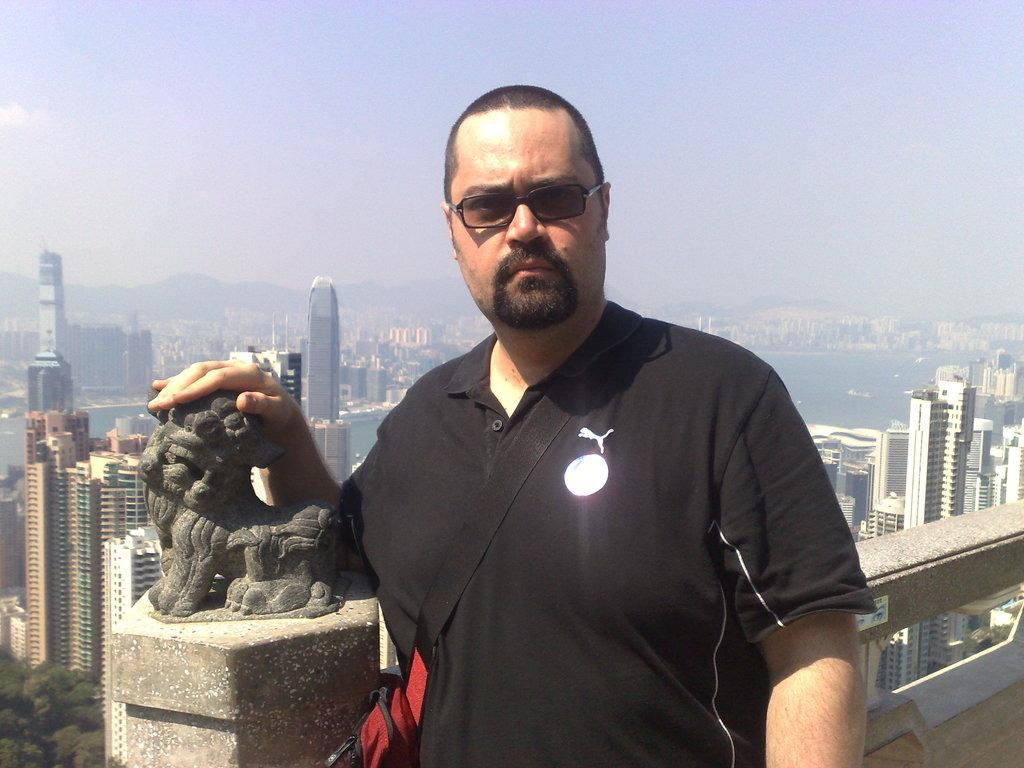Who is the main subject in the image? There is a man in the image. What is the man wearing? The man is wearing a black t-shirt. What is the man doing in the image? The man is standing in the front and giving a pose. What can be seen in the background of the image? There are skyscrapers and a mountain in the background of the image. What type of potato is being used to support the man's finger in the image? There is no potato or finger present in the image. 